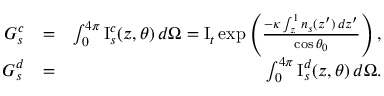Convert formula to latex. <formula><loc_0><loc_0><loc_500><loc_500>\begin{array} { r l r } { G _ { s } ^ { c } } & { = } & { \int _ { 0 } ^ { 4 \pi } I _ { s } ^ { c } ( z , \theta ) \, d \Omega = I _ { t } \exp \left ( \frac { - \kappa \int _ { z } ^ { 1 } n _ { s } ( z ^ { \prime } ) \, d z ^ { \prime } } { \cos { \theta _ { 0 } } } \right ) , } \\ { G _ { s } ^ { d } } & { = } & { \int _ { 0 } ^ { 4 \pi } I _ { s } ^ { d } ( z , \theta ) \, d \Omega . } \end{array}</formula> 